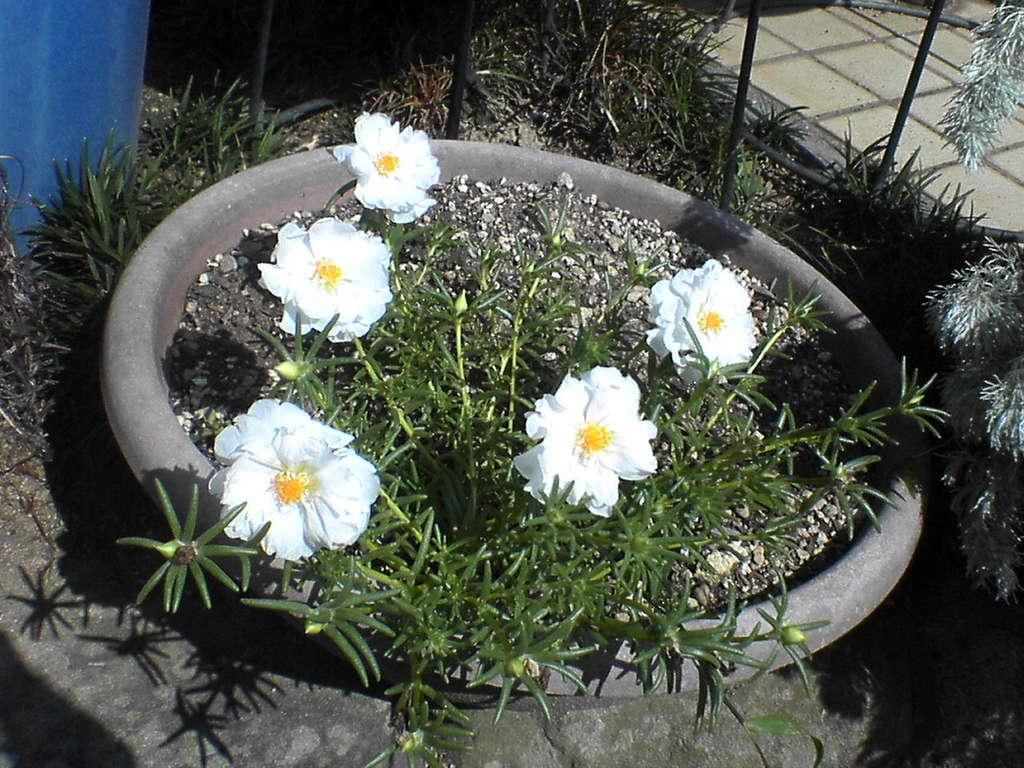What type of plant is in the image? There is a white color flower potted plant in the image. What type of surface is visible in the background of the image? There is pavement visible in the background of the image. What type of vegetation is in the background of the image? There is grass in the background of the image. What type of material is present in the background of the image? Metal rods are present in the background of the image. What color is the object in the background of the image? There is a blue color object in the background of the image. Can you see any fog in the image? There is no fog present in the image. Is there a volleyball game happening in the background of the image? There is no volleyball game or any reference to a volleyball game in the image. 